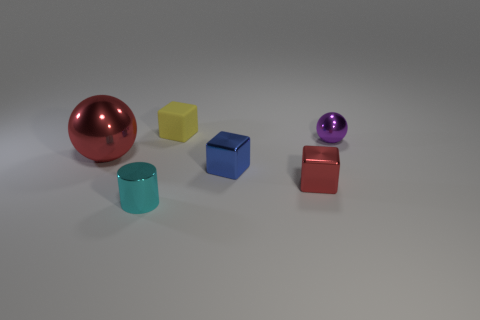Subtract all tiny metal blocks. How many blocks are left? 1 Add 2 tiny red cylinders. How many objects exist? 8 Subtract all blue blocks. How many blocks are left? 2 Subtract all spheres. How many objects are left? 4 Subtract all green blocks. How many purple balls are left? 1 Subtract all large gray metal things. Subtract all small objects. How many objects are left? 1 Add 3 tiny metallic cylinders. How many tiny metallic cylinders are left? 4 Add 1 small cyan metallic cylinders. How many small cyan metallic cylinders exist? 2 Subtract 1 blue cubes. How many objects are left? 5 Subtract 1 balls. How many balls are left? 1 